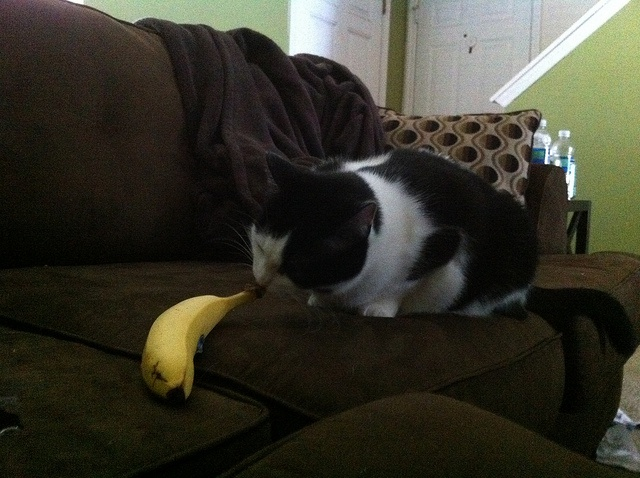Describe the objects in this image and their specific colors. I can see couch in black and gray tones, cat in black, gray, and darkgray tones, banana in black, tan, and olive tones, bottle in black, white, darkgray, teal, and lightblue tones, and bottle in black, darkgray, white, and teal tones in this image. 